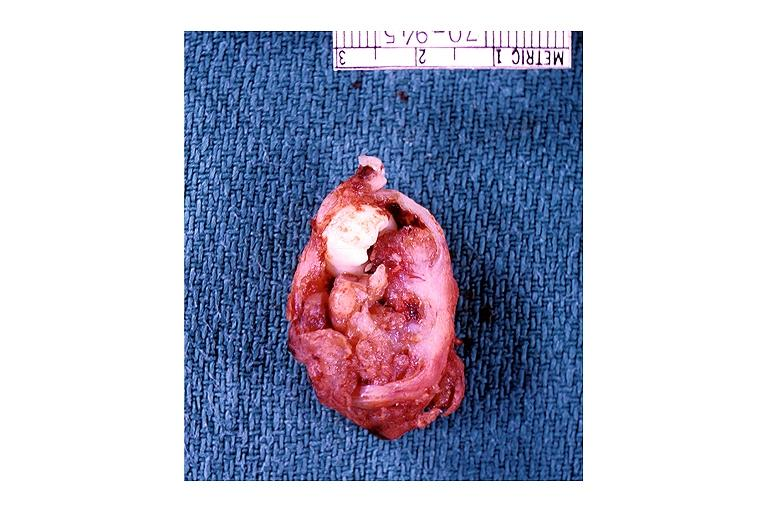what does this image show?
Answer the question using a single word or phrase. Adenomatoid odontogenic tumor 